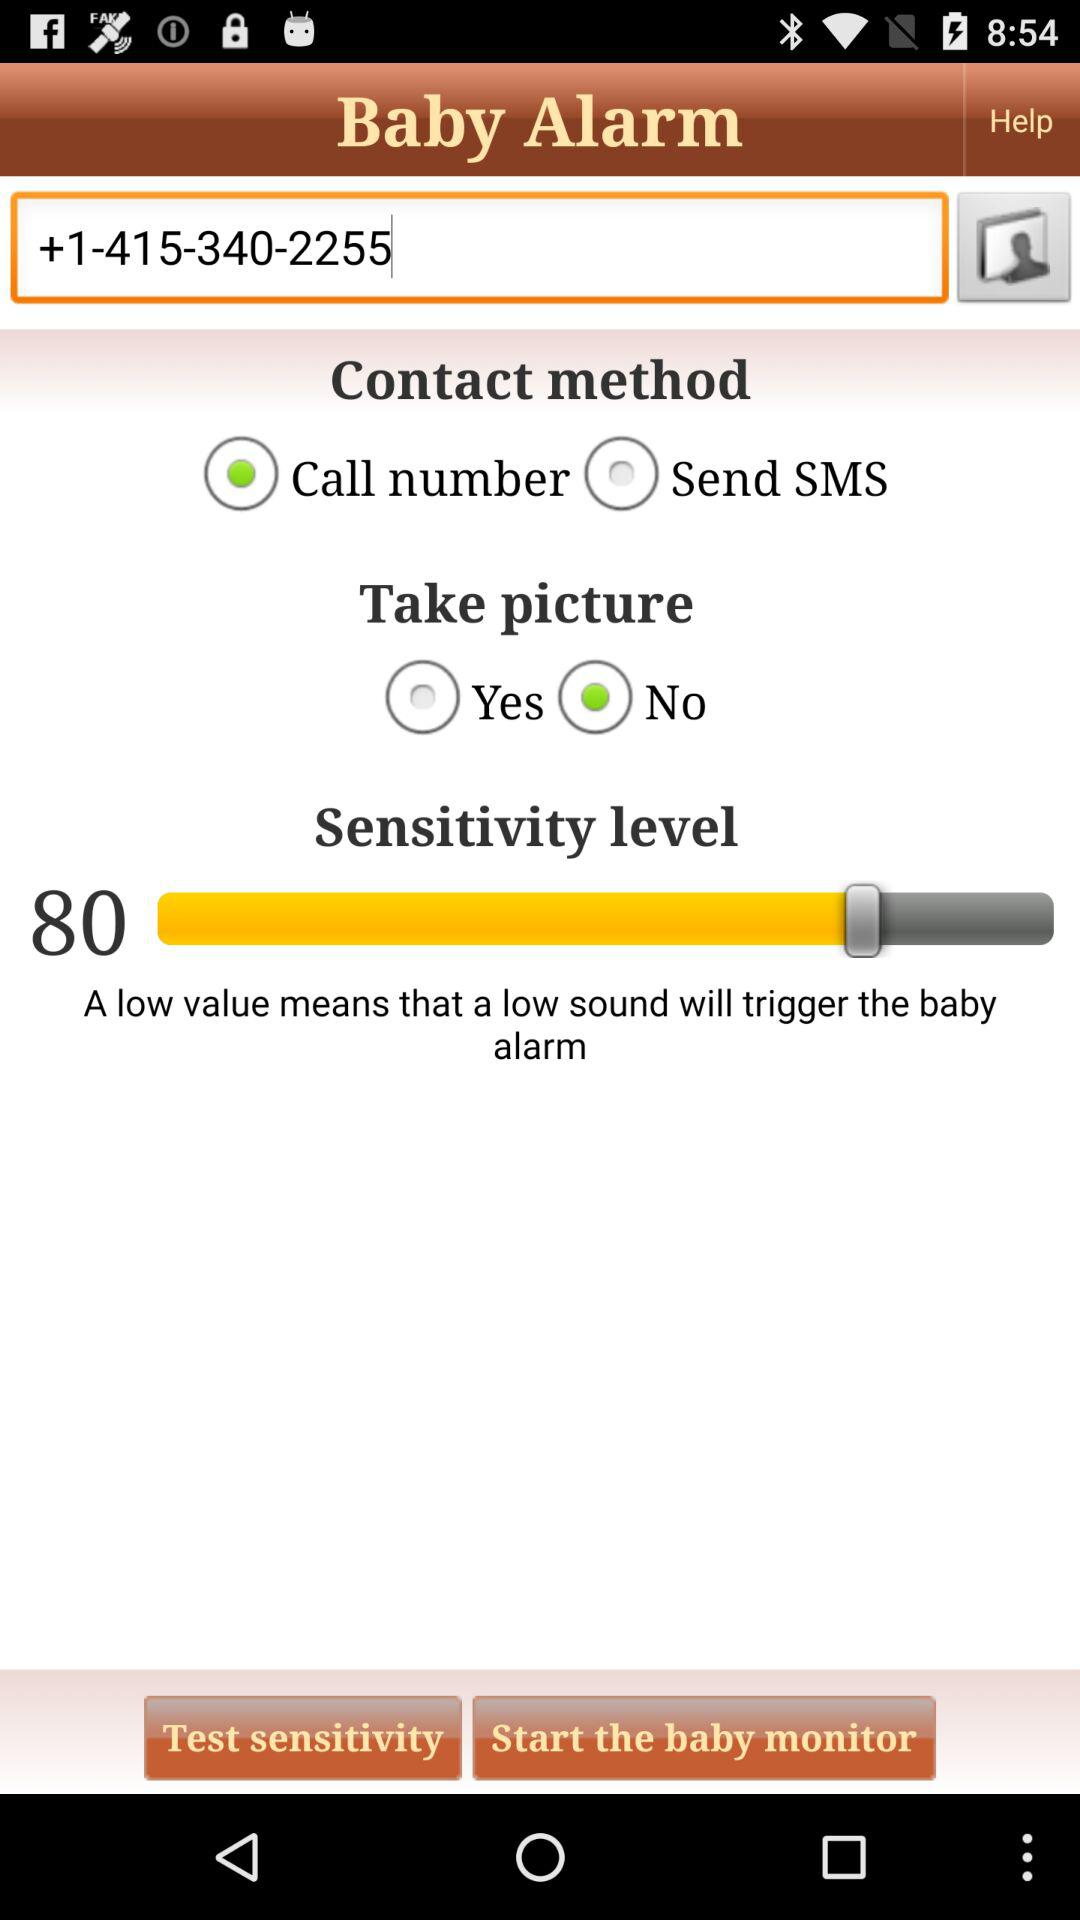What is the meaning of the low value? The low value means that a low sound will trigger the baby alarm. 